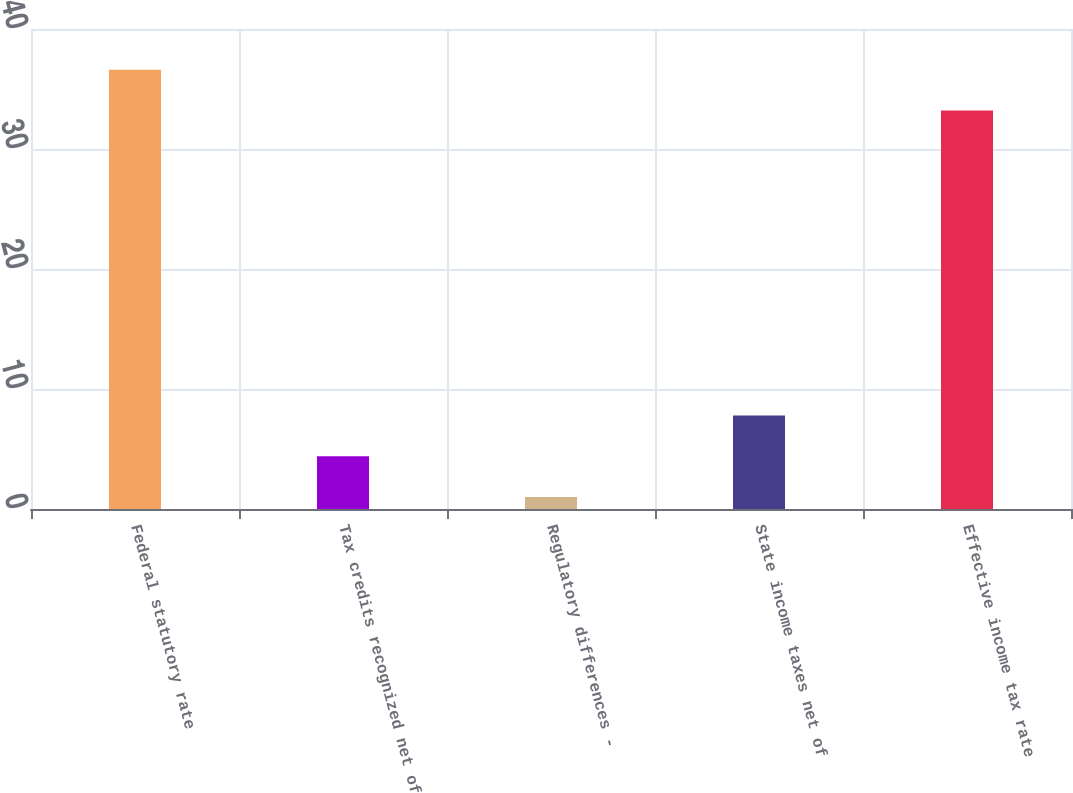Convert chart to OTSL. <chart><loc_0><loc_0><loc_500><loc_500><bar_chart><fcel>Federal statutory rate<fcel>Tax credits recognized net of<fcel>Regulatory differences -<fcel>State income taxes net of<fcel>Effective income tax rate<nl><fcel>36.6<fcel>4.4<fcel>1<fcel>7.8<fcel>33.2<nl></chart> 